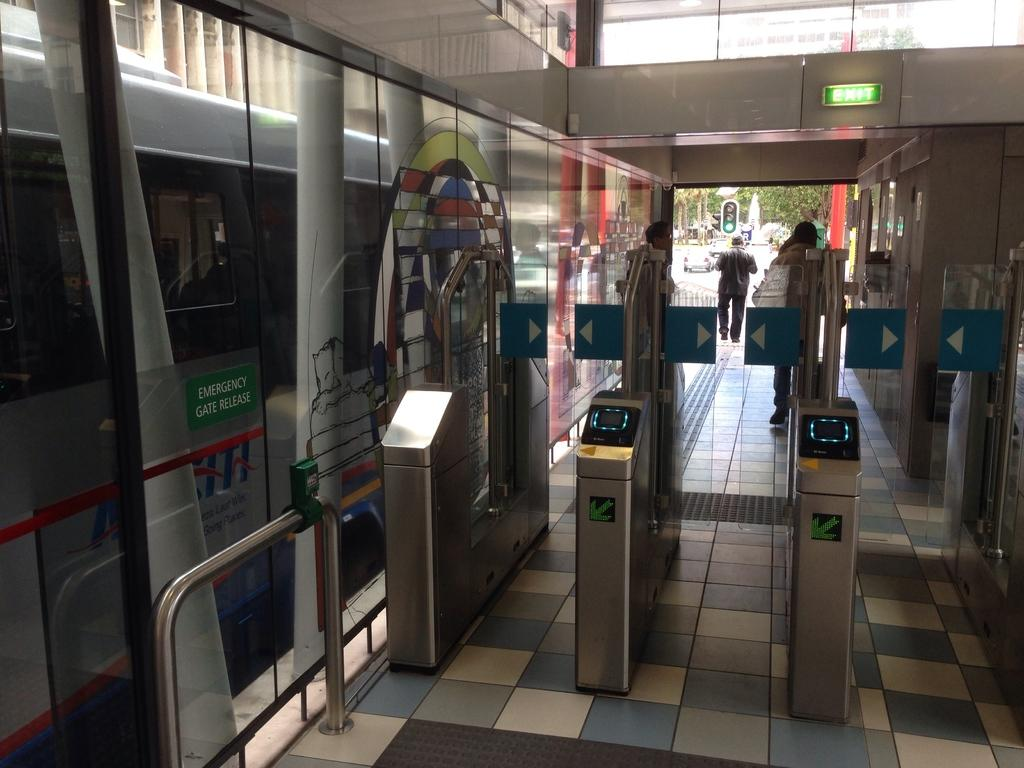<image>
Describe the image concisely. The emergency gate release is in front of the train close to the card readers. 